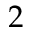<formula> <loc_0><loc_0><loc_500><loc_500>2</formula> 